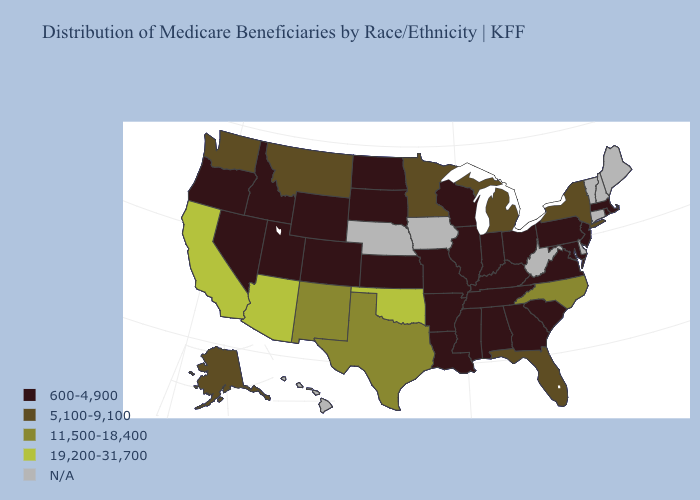Name the states that have a value in the range 600-4,900?
Answer briefly. Alabama, Arkansas, Colorado, Georgia, Idaho, Illinois, Indiana, Kansas, Kentucky, Louisiana, Maryland, Massachusetts, Mississippi, Missouri, Nevada, New Jersey, North Dakota, Ohio, Oregon, Pennsylvania, Rhode Island, South Carolina, South Dakota, Tennessee, Utah, Virginia, Wisconsin, Wyoming. What is the highest value in the South ?
Concise answer only. 19,200-31,700. Does Idaho have the highest value in the USA?
Concise answer only. No. What is the lowest value in the USA?
Write a very short answer. 600-4,900. Which states have the lowest value in the USA?
Quick response, please. Alabama, Arkansas, Colorado, Georgia, Idaho, Illinois, Indiana, Kansas, Kentucky, Louisiana, Maryland, Massachusetts, Mississippi, Missouri, Nevada, New Jersey, North Dakota, Ohio, Oregon, Pennsylvania, Rhode Island, South Carolina, South Dakota, Tennessee, Utah, Virginia, Wisconsin, Wyoming. What is the value of Vermont?
Concise answer only. N/A. Which states have the highest value in the USA?
Be succinct. Arizona, California, Oklahoma. Which states hav the highest value in the West?
Short answer required. Arizona, California. What is the highest value in states that border South Carolina?
Answer briefly. 11,500-18,400. Name the states that have a value in the range 5,100-9,100?
Keep it brief. Alaska, Florida, Michigan, Minnesota, Montana, New York, Washington. Name the states that have a value in the range 19,200-31,700?
Quick response, please. Arizona, California, Oklahoma. Which states have the lowest value in the USA?
Quick response, please. Alabama, Arkansas, Colorado, Georgia, Idaho, Illinois, Indiana, Kansas, Kentucky, Louisiana, Maryland, Massachusetts, Mississippi, Missouri, Nevada, New Jersey, North Dakota, Ohio, Oregon, Pennsylvania, Rhode Island, South Carolina, South Dakota, Tennessee, Utah, Virginia, Wisconsin, Wyoming. What is the value of New Mexico?
Quick response, please. 11,500-18,400. 